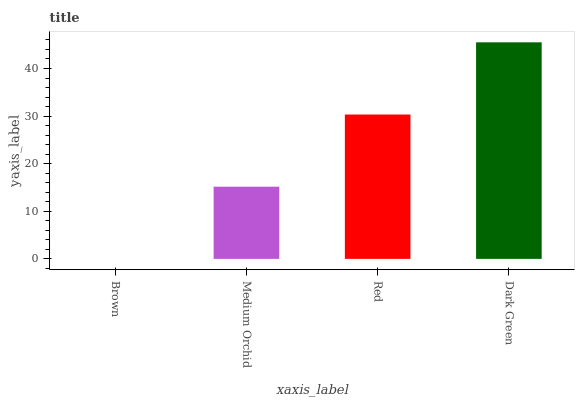Is Brown the minimum?
Answer yes or no. Yes. Is Dark Green the maximum?
Answer yes or no. Yes. Is Medium Orchid the minimum?
Answer yes or no. No. Is Medium Orchid the maximum?
Answer yes or no. No. Is Medium Orchid greater than Brown?
Answer yes or no. Yes. Is Brown less than Medium Orchid?
Answer yes or no. Yes. Is Brown greater than Medium Orchid?
Answer yes or no. No. Is Medium Orchid less than Brown?
Answer yes or no. No. Is Red the high median?
Answer yes or no. Yes. Is Medium Orchid the low median?
Answer yes or no. Yes. Is Brown the high median?
Answer yes or no. No. Is Brown the low median?
Answer yes or no. No. 